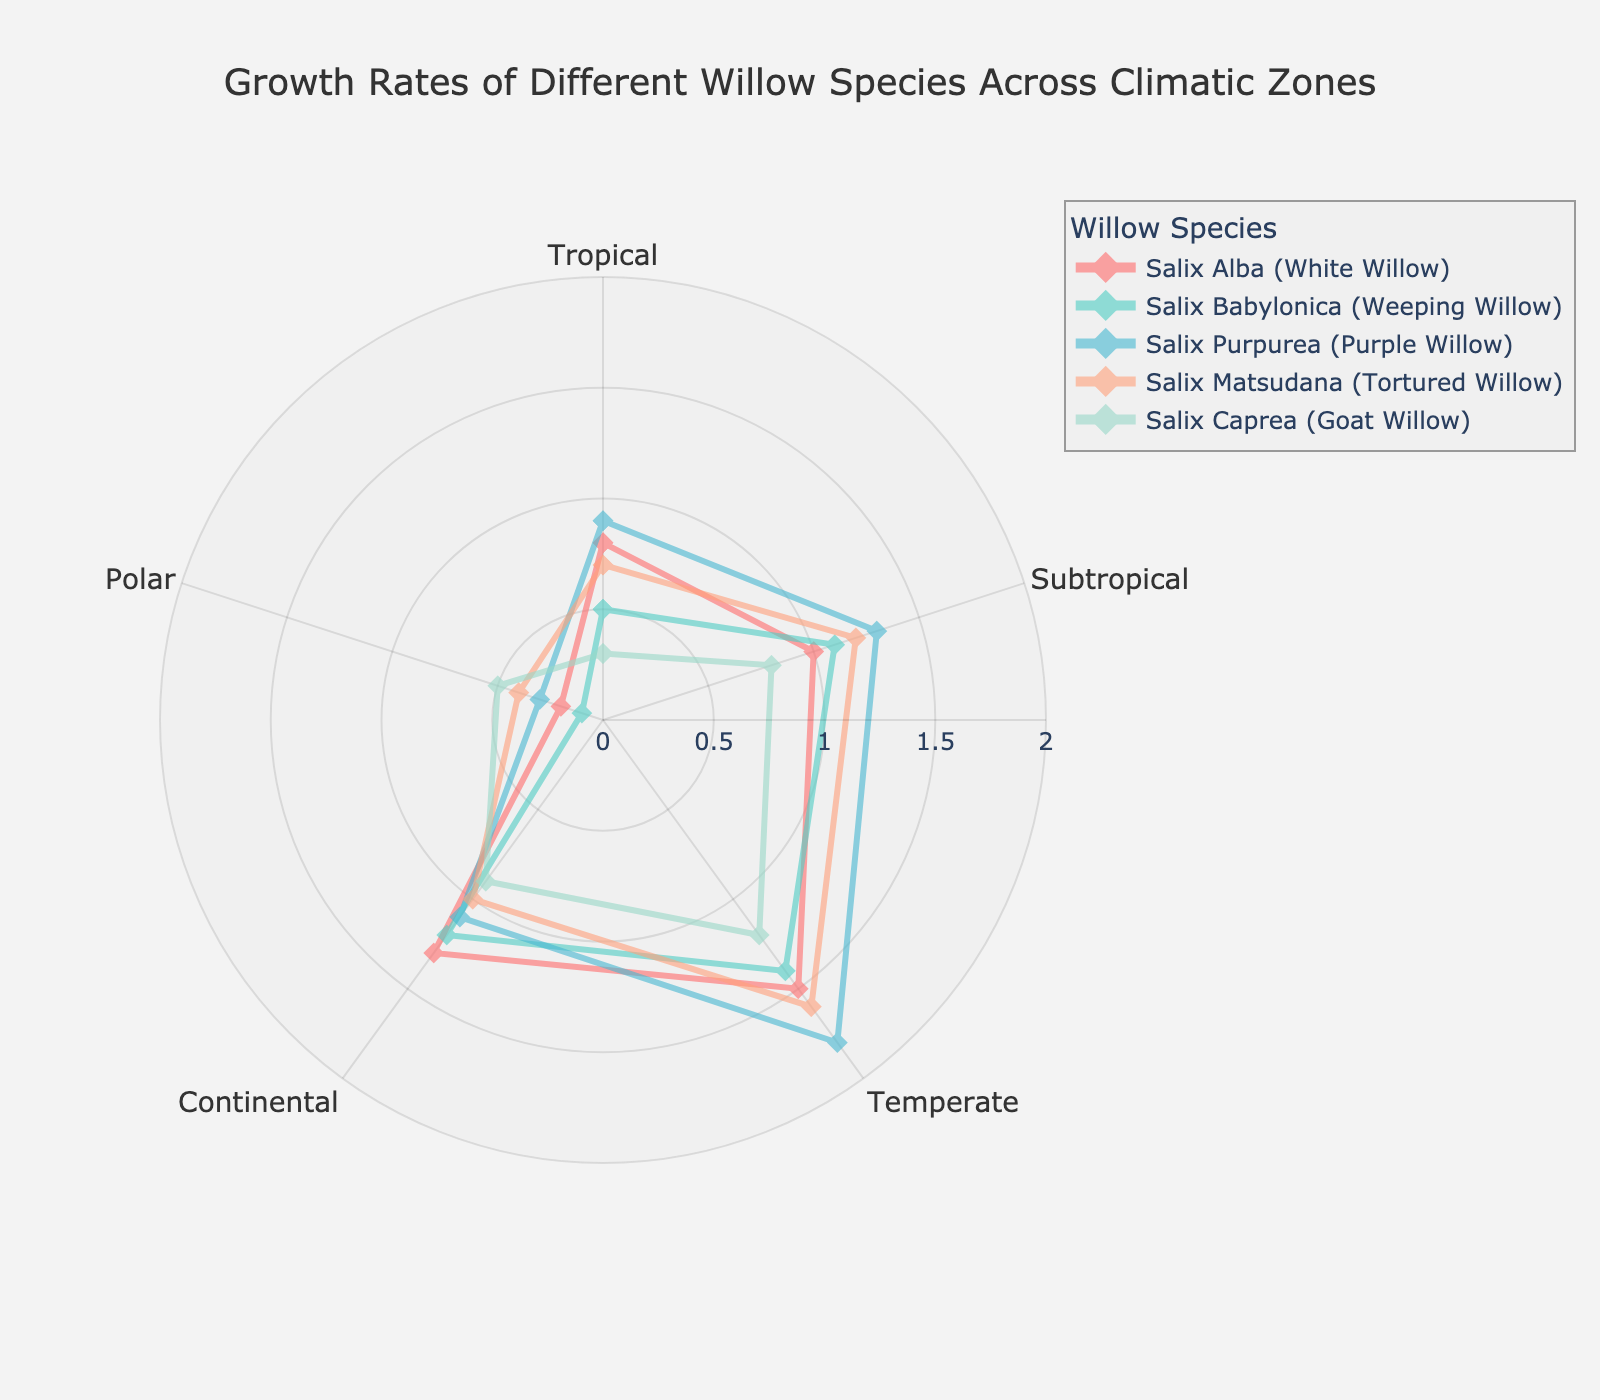which species has the highest growth rate in the temperate zone? Look at the values for each species in the temperate zone and compare them. Salix Purpurea has the highest value at 1.8.
Answer: Salix Purpurea which climate zone shows the lowest growth rate for Salix Babylonica? Compare the growth rates of Salix Babylonica across all climate zones. The Polar zone has the lowest rate at 0.1.
Answer: Polar is Salix Alba's growth rate in the continental zone higher or lower than its growth rate in the subtropical zone? Compare Salix Alba's growth rate in the continental zone (1.3) with its rate in the subtropical zone (1.0). The growth rate in the continental zone is higher.
Answer: Higher what is the average growth rate of Salix Matsudana across all climate zones? Sum the growth rates for Salix Matsudana (0.7 + 1.2 + 1.6 + 1.0 + 0.4) and divide by the number of climate zones (5): (0.7 + 1.2 + 1.6 + 1.0 + 0.4) / 5 = 4.9 / 5 = 0.98.
Answer: 0.98 which two species have identical growth rates in any zone and what is the value? Identify any climate zone where two species have the same growth rate. In the Polar zone, Salix Matsudana and Salix Caprea both have a growth rate of 0.4.
Answer: Salix Matsudana and Salix Caprea; 0.4 how much higher is the growth rate of Salix Purpurea in the subtropical zone compared to the tropical zone? Subtract the growth rate of Salix Purpurea in the tropical zone (0.9) from its rate in the subtropical zone (1.3): 1.3 - 0.9 = 0.4.
Answer: 0.4 is the pattern of growth rates for Salix Caprea more uniform compared to Salix Purpurea across the climatic zones? Compare the variation in growth rates for each species across the zones. Salix Caprea has smaller differences between values (0.3, 0.8, 1.2, 0.9, 0.5), while Salix Purpurea has larger variations (0.9, 1.3, 1.8, 1.1, 0.3). Hence, Salix Caprea shows a more uniform pattern.
Answer: Yes which species shows the steepest decline in growth rate when moving from the temperate to continental zone? Look at the difference between the temperate and continental zones for each species. Salix Purpurea drops from 1.8 to 1.1, the largest decline of 0.7.
Answer: Salix Purpurea what is the total growth rate for Salix Alba across all zones? Sum the growth rates of Salix Alba across all climate zones: 0.8 + 1.0 + 1.5 + 1.3 + 0.2 = 4.8.
Answer: 4.8 